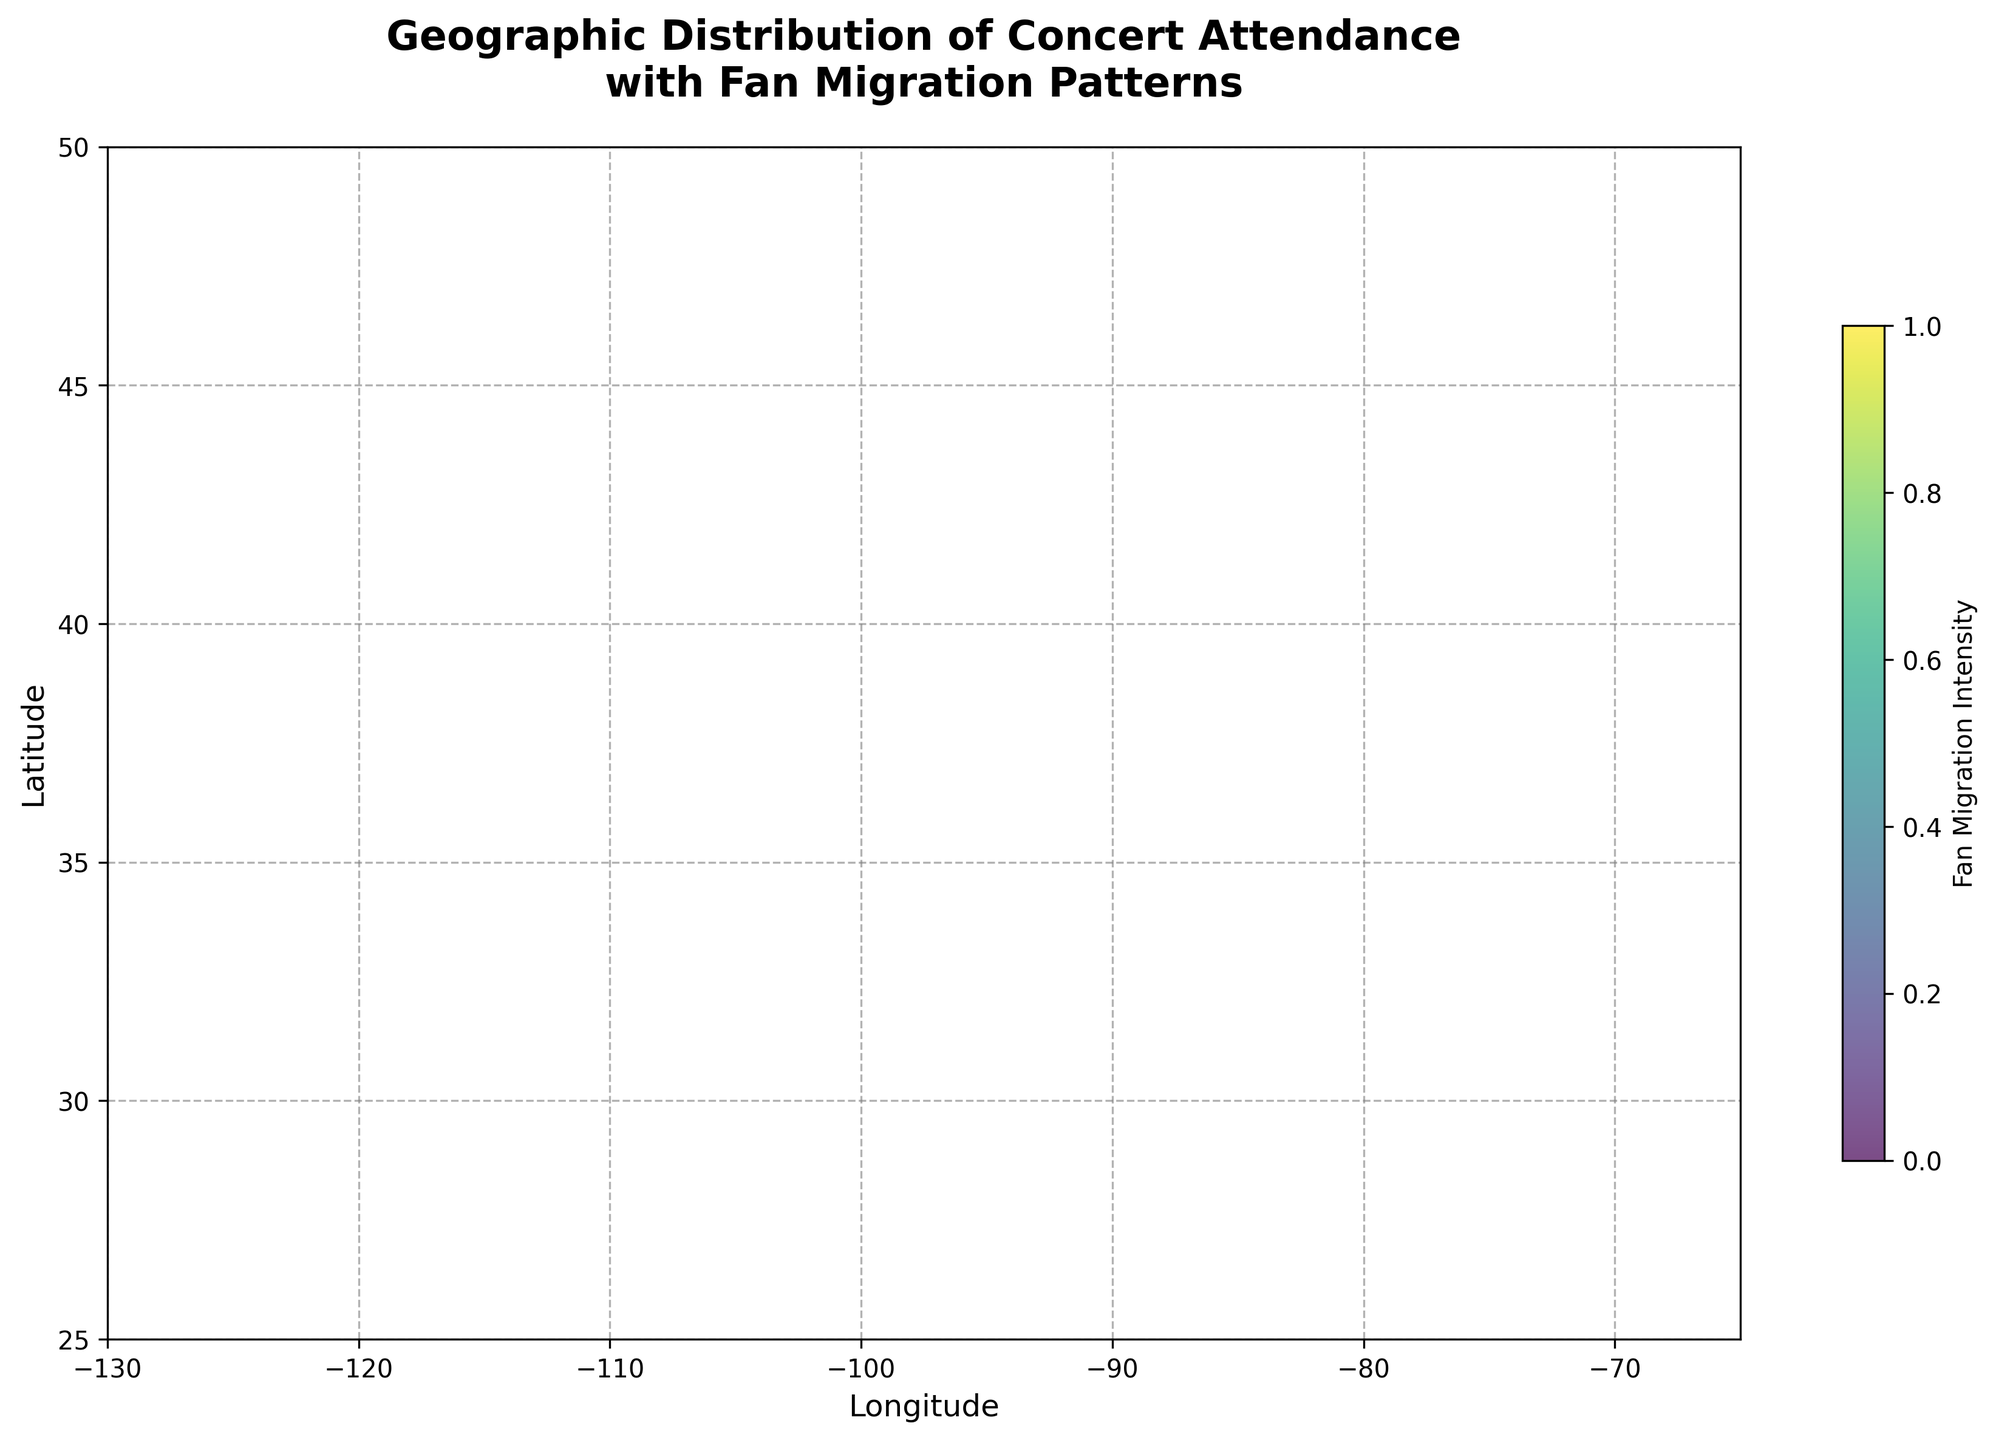How many cities are shown in the plot? Count the number of unique city labels. There are 10 cities labeled on the plot.
Answer: 10 What is the title of the plot? The title is the text at the top, centered. It reads "Geographic Distribution of Concert Attendance with Fan Migration Patterns."
Answer: Geographic Distribution of Concert Attendance with Fan Migration Patterns Which city shows the strongest fan migration intensity? Identify the longest arrow as migration intensity is represented by arrow length. The longest arrow is from Las Vegas.
Answer: Las Vegas In which city does Taylor Swift have a significant fan base, and in what direction are her fans migrating? Locate Taylor Swift in New York, and observe the direction of the arrow starting from New York. It shows fans are migrating primarily to the north-east.
Answer: New York, north-east Which artist's fans are migrating predominantly to the south-west? Look at the directions of arrows and the annotation of artists. Fans of Ariana Grande in Boston are migrating to the south-west.
Answer: Ariana Grande Compare the migration patterns for Drake and Justin Bieber. Who has fans migrating more towards the northwest? Compare the vectors starting from Los Angeles (Drake) and Washington D.C. (Justin Bieber). Drake's fans in Los Angeles have a higher northwest component.
Answer: Drake What are the coordinates (approximate latitude and longitude) of Chicago? The figure shows Chicago around the coordinates (41.8781, -87.6298). Read these coordinates directly from the plot annotations.
Answer: (41.8781, -87.6298) Which city shows fan migration towards the south-east, and which artist is associated with it? Observe the arrows pointing towards the south-east direction. Philadelphia (The Weeknd) and Atlanta (Rihanna) show this pattern.
Answer: Philadelphia, The Weeknd; Atlanta, Rihanna Identify the cities where fans are migrating outward in both northern and eastern directions. Look for arrows pointing towards the upper right quadrant. New York (Taylor Swift), Philadelphia (The Weeknd), and Atlanta (Rihanna) match the criteria.
Answer: New York, Philadelphia, Atlanta Count how many arrows point predominantly westward and name the cities associated with them. Identify arrows with significant negative u-components. The cities with westward arrows are Los Angeles (Drake), Houston (Ed Sheeran), and Washington D.C. (Justin Bieber).
Answer: 3 (Los Angeles, Houston, Washington D.C.) 